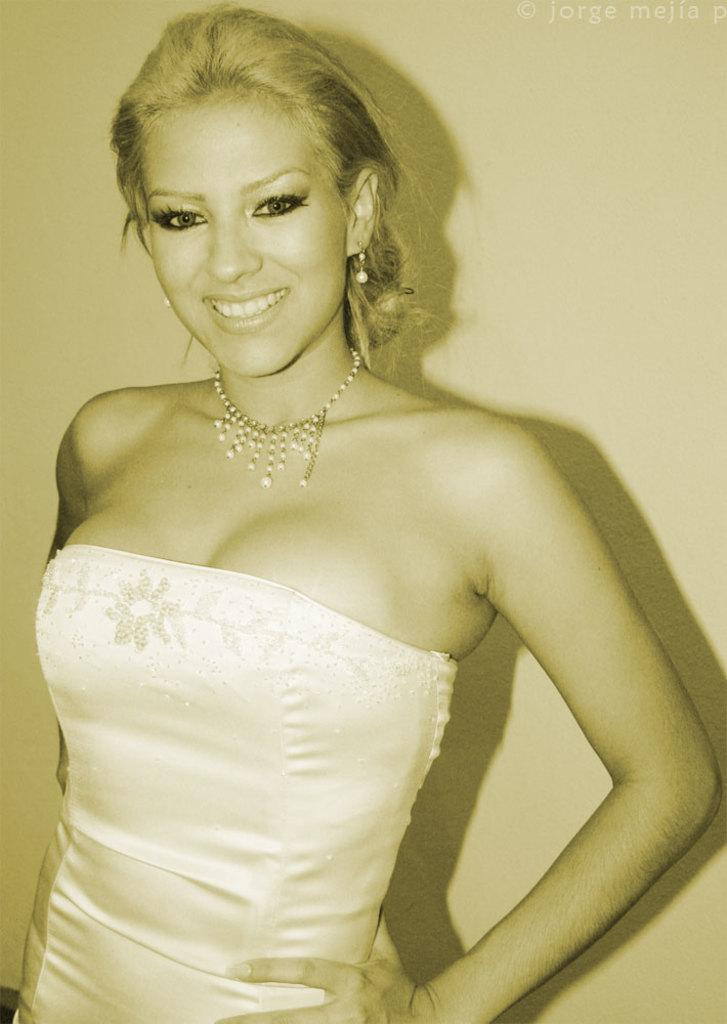Who is present in the image? There is a woman in the image. What is the woman doing in the image? The woman is standing and smiling. Can you describe any additional details about the woman's presence in the image? There is a shadow of the woman on the wall in the background of the image. What type of lunch is the woman eating in the image? There is no lunch present in the image; the woman is standing and smiling. How many dogs are visible in the image? There are no dogs present in the image. 